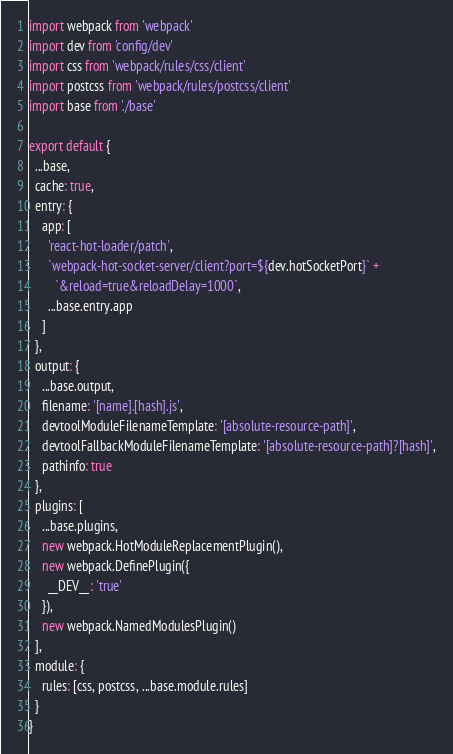<code> <loc_0><loc_0><loc_500><loc_500><_JavaScript_>import webpack from 'webpack'
import dev from 'config/dev'
import css from 'webpack/rules/css/client'
import postcss from 'webpack/rules/postcss/client'
import base from './base'

export default {
  ...base,
  cache: true,
  entry: {
    app: [
      'react-hot-loader/patch',
      `webpack-hot-socket-server/client?port=${dev.hotSocketPort}` +
        `&reload=true&reloadDelay=1000`,
      ...base.entry.app
    ]
  },
  output: {
    ...base.output,
    filename: '[name].[hash].js',
    devtoolModuleFilenameTemplate: '[absolute-resource-path]',
    devtoolFallbackModuleFilenameTemplate: '[absolute-resource-path]?[hash]',
    pathinfo: true
  },
  plugins: [
    ...base.plugins,
    new webpack.HotModuleReplacementPlugin(),
    new webpack.DefinePlugin({
      __DEV__: 'true'
    }),
    new webpack.NamedModulesPlugin()
  ],
  module: {
    rules: [css, postcss, ...base.module.rules]
  }
}
</code> 